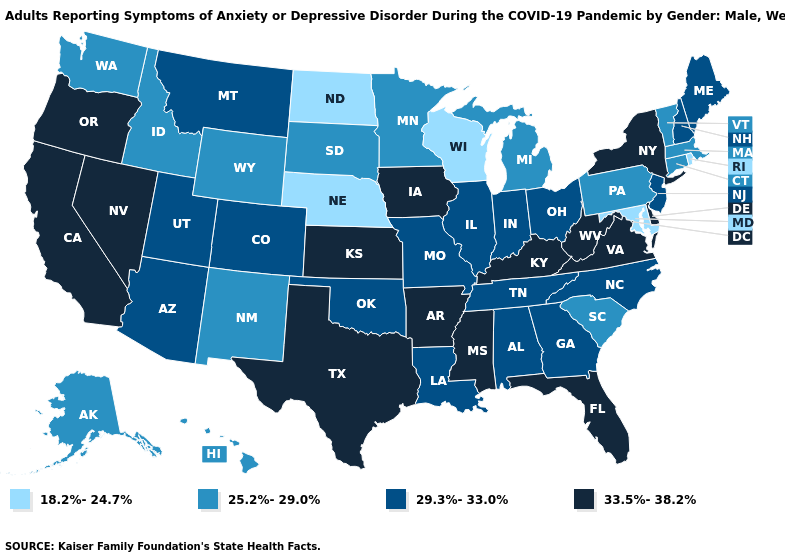What is the lowest value in the USA?
Keep it brief. 18.2%-24.7%. What is the lowest value in the West?
Write a very short answer. 25.2%-29.0%. What is the value of Rhode Island?
Write a very short answer. 18.2%-24.7%. What is the value of Massachusetts?
Concise answer only. 25.2%-29.0%. Does Utah have the highest value in the USA?
Quick response, please. No. Name the states that have a value in the range 29.3%-33.0%?
Quick response, please. Alabama, Arizona, Colorado, Georgia, Illinois, Indiana, Louisiana, Maine, Missouri, Montana, New Hampshire, New Jersey, North Carolina, Ohio, Oklahoma, Tennessee, Utah. Name the states that have a value in the range 29.3%-33.0%?
Give a very brief answer. Alabama, Arizona, Colorado, Georgia, Illinois, Indiana, Louisiana, Maine, Missouri, Montana, New Hampshire, New Jersey, North Carolina, Ohio, Oklahoma, Tennessee, Utah. What is the value of Kansas?
Write a very short answer. 33.5%-38.2%. Among the states that border Oregon , which have the lowest value?
Answer briefly. Idaho, Washington. Name the states that have a value in the range 33.5%-38.2%?
Quick response, please. Arkansas, California, Delaware, Florida, Iowa, Kansas, Kentucky, Mississippi, Nevada, New York, Oregon, Texas, Virginia, West Virginia. What is the value of New Jersey?
Quick response, please. 29.3%-33.0%. Among the states that border Massachusetts , does Connecticut have the highest value?
Write a very short answer. No. How many symbols are there in the legend?
Answer briefly. 4. Which states have the lowest value in the Northeast?
Concise answer only. Rhode Island. Among the states that border Georgia , does Alabama have the highest value?
Concise answer only. No. 